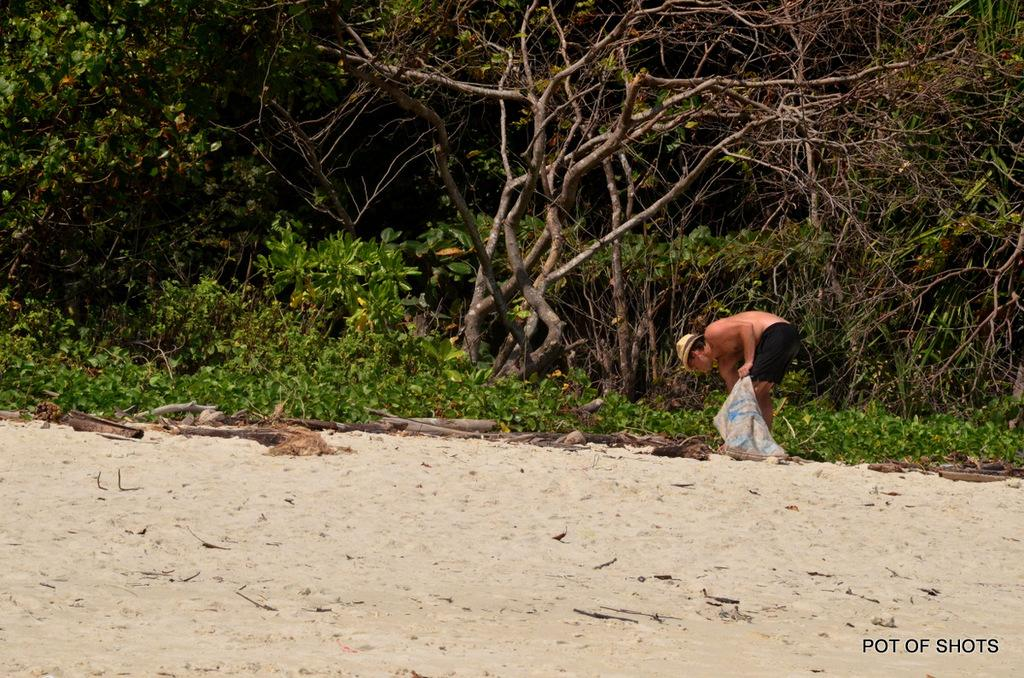What is located in the foreground of the picture? There are wooden logs and sand in the foreground of the picture. What can be seen in the center of the picture? There are plants and trees in the center of the picture, as well as a person holding a bag. Can you describe the person in the center of the picture? The person in the center of the picture is holding a bag. What type of food is the frog eating in the picture? There is no frog present in the picture, and therefore no such activity can be observed. What message of peace can be seen in the picture? There is no message of peace depicted in the image; it features wooden logs, sand, plants, trees, and a person holding a bag. 